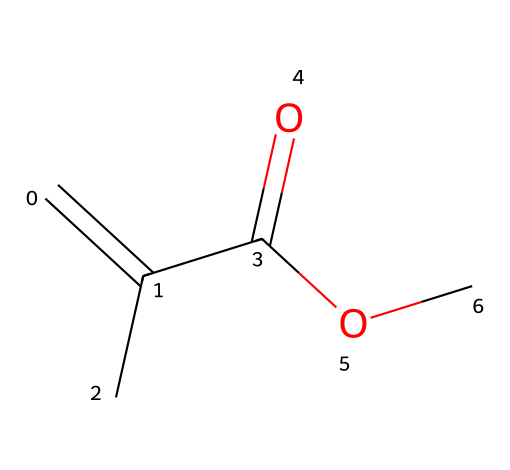What type of functional group is present in this molecule? The molecule has an ester functional group indicated by the presence of the C(=O)OC structure, where a carbonyl (C=O) is directly attached to an oxygen that is connected to another carbon chain.
Answer: ester How many carbon atoms are in this structure? By examining the SMILES notation, we see two carbon atoms in the C=C part (making a double bond), one carbon in the carbonyl (C=O), and one in the methyl group (C). Therefore, there are four carbon atoms in total.
Answer: four What is the degree of unsaturation in this molecule? The degree of unsaturation can be calculated by utilizing the presence of double bonds and rings. In this chemical, there is one double bond (C=C) contributing one degree of unsaturation, leading to a total of one.
Answer: one What is the molecular formula of this compound? Upon analyzing the SMILES representation, we count the atoms: 4 carbons (C), 6 hydrogens (H), and 2 oxygens (O), resulting in the formula C4H6O2.
Answer: C4H6O2 What type of reaction might this acrylic monomer undergo in set construction? Acrylic monomers, like this one, can undergo polymerization reactions where they join to form larger polymer chains, commonly used in the production of durable, lightweight materials for set construction.
Answer: polymerization What role does the carbonyl group play in this monomer's properties? The carbonyl group (C=O) in this monomer is critical for its reactivity and contributes to the material's adhesive properties, impacting how it bonds and interacts with other materials in studio set construction.
Answer: reactivity and adhesion 